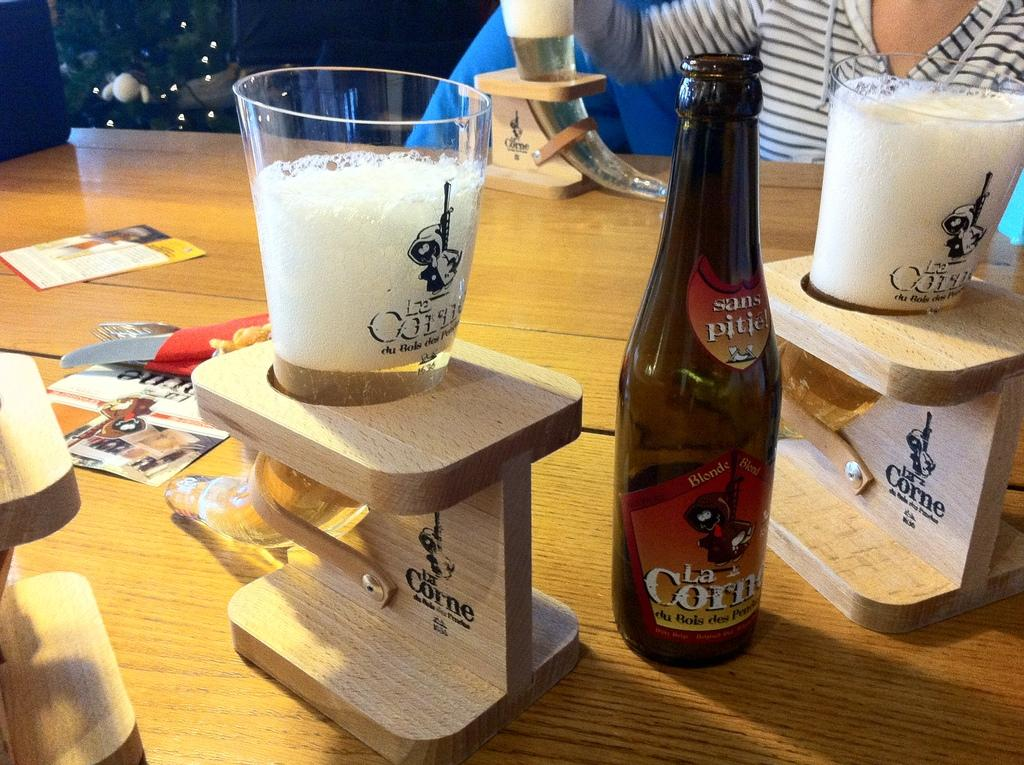<image>
Summarize the visual content of the image. La Corne bottle of liquor is poured in horned shaped glasses on a table 